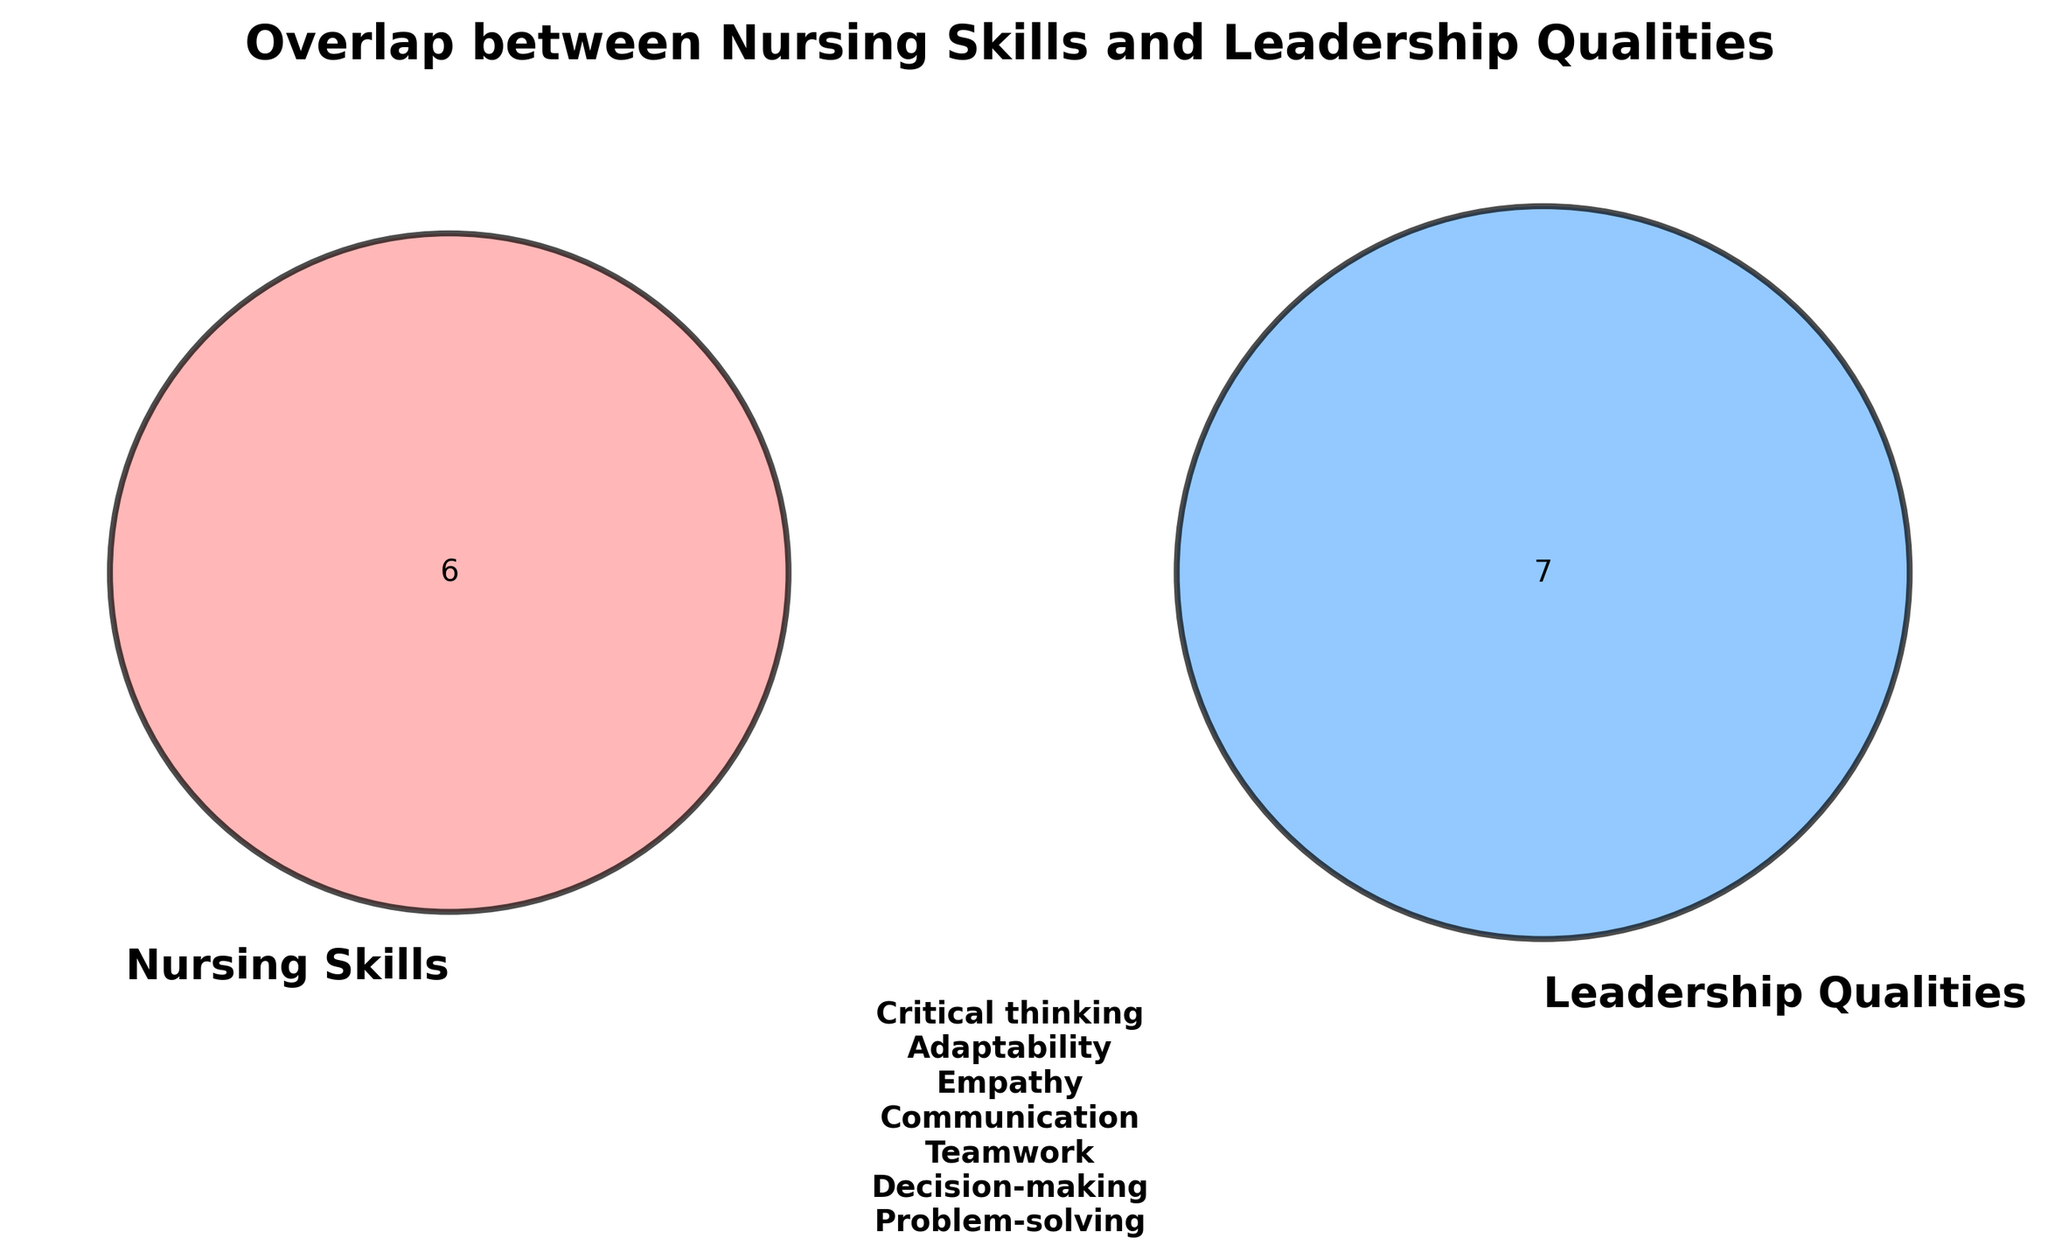what are the two main categories in the Venn Diagram? The main categories are represented by the two overlapping circles, each labeled.
Answer: Nursing Skills and Leadership Qualities which category does 'Vision' belong to? Since 'Vision' is listed under Leadership Qualities, it belongs to the Leadership Qualities category.
Answer: Leadership Qualities how are the overlapping sections of the two categories colored? The overlapping section blends the colors of the two circles, creating a mix of the two colors.
Answer: Mixed color of red and blue what is the main piece of text displayed below the Venn diagram? The main text lists the overlapping skills, which are common to both Nursing Skills and Leadership Qualities.
Answer: communication, decision-making, empathy, problem-solving, teamwork, adaptability, critical thinking how many unique skills are there in total across both categories? Count unique skills listed under both Nursing Skills and Leadership Qualities and excluding overlaps.
Answer: 17 why is 'Charisma' only present in one circle? 'Charisma' belongs to Leadership Qualities and does not overlap with any nursing skill.
Answer: It is a unique leadership quality how does ‘Critical thinking’ fit into the Venn diagram? 'Critical thinking' is part of the overlap, meaning it is both a Nursing Skill and a Leadership Quality.
Answer: Overlap compare the number of items in each category. Which has more, Nursing Skills or Leadership Qualities? Count items in Nursing Skills and compare with items in Leadership Qualities. Leadership Qualities have more items.
Answer: Leadership Qualities where would 'Conflict resolution' be placed in the Venn diagram? Based on the list, it would be in the Leadership Qualities circle only.
Answer: Leadership Qualities what does the title of the diagram indicate? The title explains that the diagram shows skills that overlap between Nursing Skills and Leadership Qualities.
Answer: Overlap between Nursing Skills and Leadership Qualities 